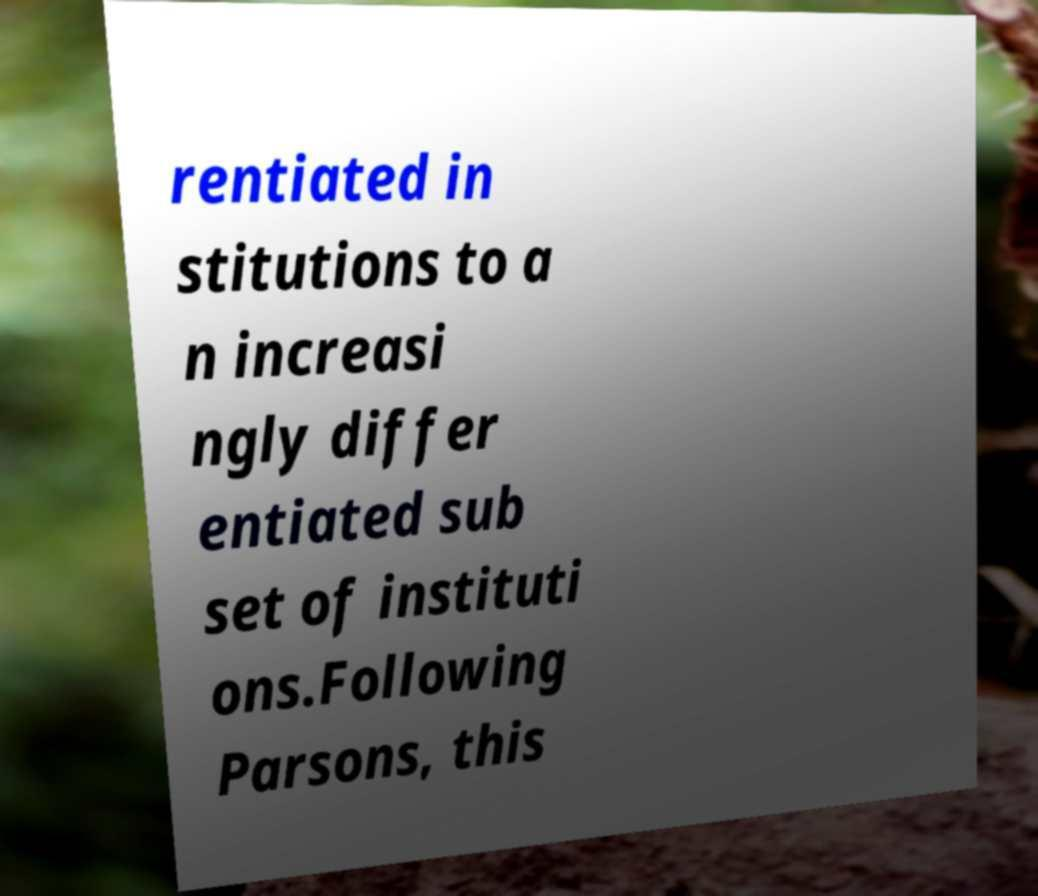Can you read and provide the text displayed in the image?This photo seems to have some interesting text. Can you extract and type it out for me? rentiated in stitutions to a n increasi ngly differ entiated sub set of instituti ons.Following Parsons, this 